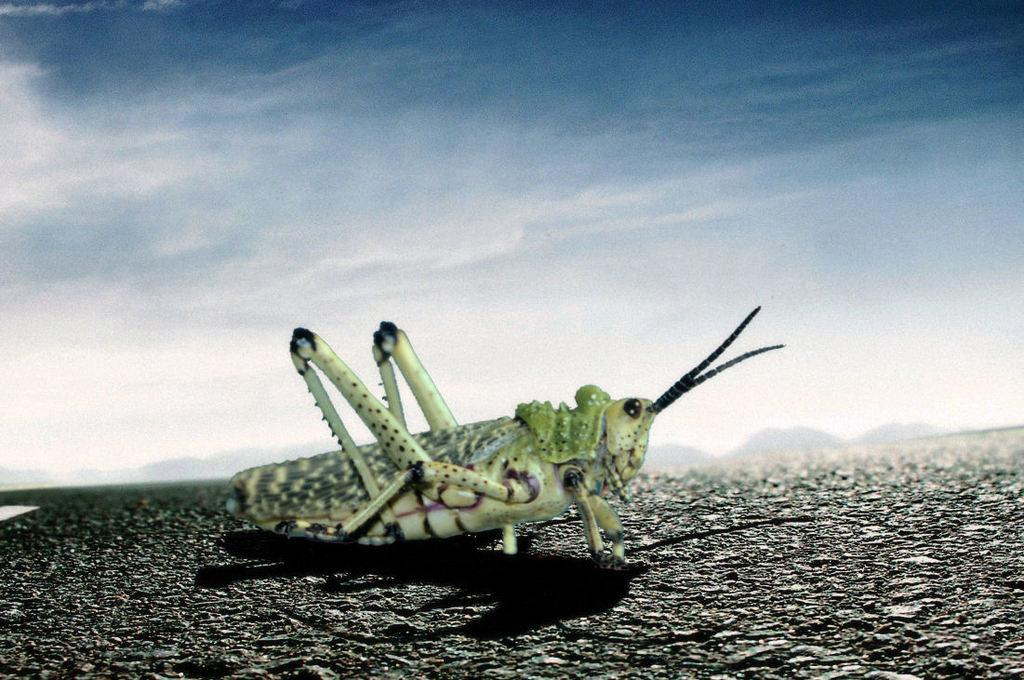What type of insect can be seen in the picture? There is a grasshopper in the picture. What is located at the bottom of the picture? There is a road at the bottom of the picture. What can be seen in the background of the picture? There are hills in the background of the picture. What is visible at the top of the picture? The sky is visible at the top of the picture. Can you describe the nature of the image? The image might be a graphical representation. Where is the oven located in the picture? There is no oven present in the picture. Is there a volcano visible in the background of the image? No, there is no volcano visible in the background of the image; there are hills instead. 